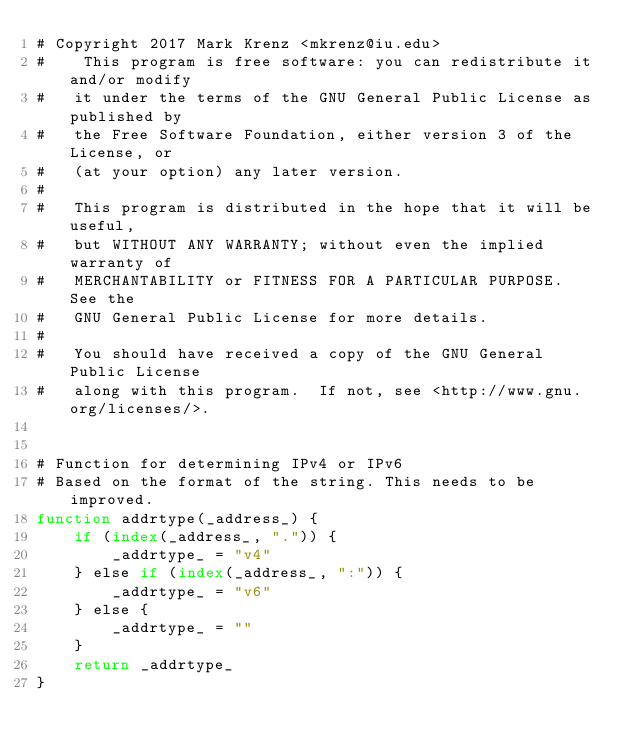Convert code to text. <code><loc_0><loc_0><loc_500><loc_500><_Awk_># Copyright 2017 Mark Krenz <mkrenz@iu.edu>
#    This program is free software: you can redistribute it and/or modify
#   it under the terms of the GNU General Public License as published by
#   the Free Software Foundation, either version 3 of the License, or
#   (at your option) any later version.
#
#   This program is distributed in the hope that it will be useful,
#   but WITHOUT ANY WARRANTY; without even the implied warranty of
#   MERCHANTABILITY or FITNESS FOR A PARTICULAR PURPOSE.  See the
#   GNU General Public License for more details.
#
#   You should have received a copy of the GNU General Public License
#   along with this program.  If not, see <http://www.gnu.org/licenses/>.


# Function for determining IPv4 or IPv6
# Based on the format of the string. This needs to be improved.
function addrtype(_address_) {
    if (index(_address_, ".")) {
        _addrtype_ = "v4"
    } else if (index(_address_, ":")) {
        _addrtype_ = "v6"
    } else {
        _addrtype_ = ""
    }
    return _addrtype_
}


</code> 